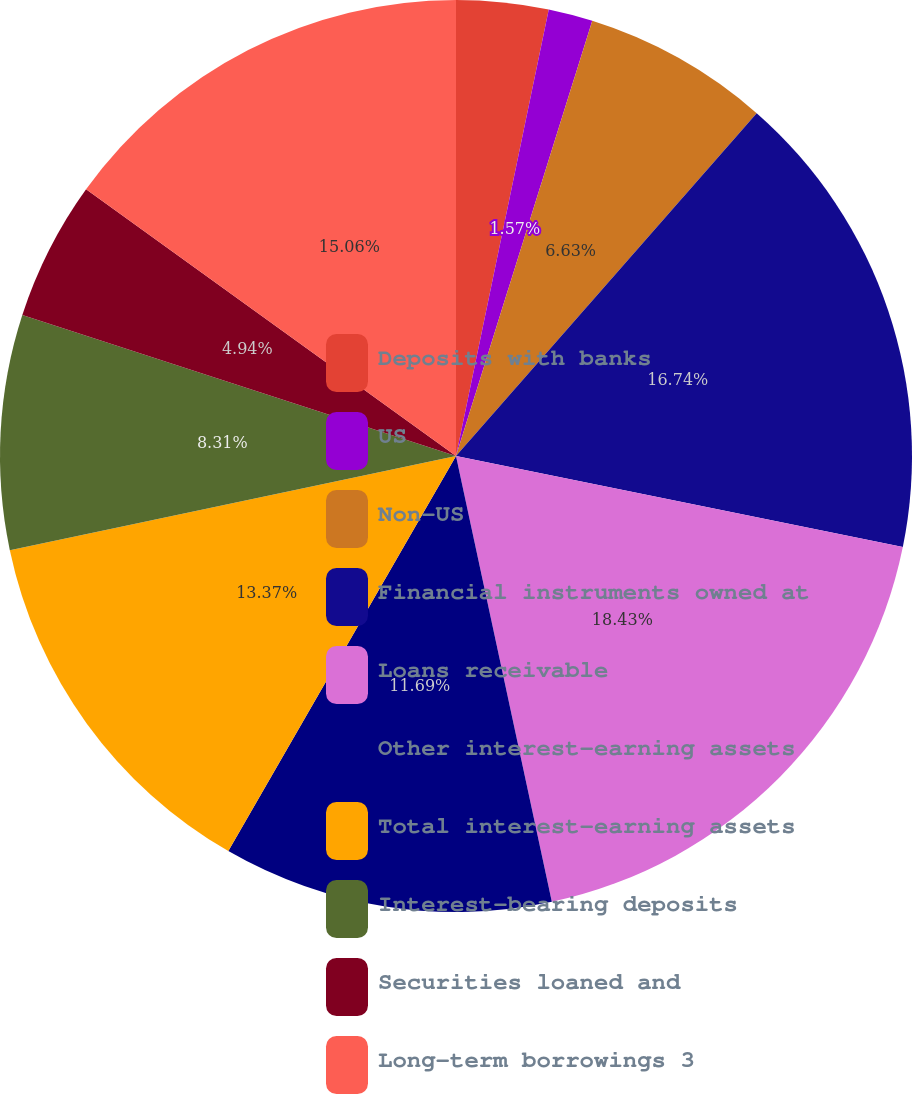<chart> <loc_0><loc_0><loc_500><loc_500><pie_chart><fcel>Deposits with banks<fcel>US<fcel>Non-US<fcel>Financial instruments owned at<fcel>Loans receivable<fcel>Other interest-earning assets<fcel>Total interest-earning assets<fcel>Interest-bearing deposits<fcel>Securities loaned and<fcel>Long-term borrowings 3<nl><fcel>3.26%<fcel>1.57%<fcel>6.63%<fcel>16.74%<fcel>18.43%<fcel>11.69%<fcel>13.37%<fcel>8.31%<fcel>4.94%<fcel>15.06%<nl></chart> 